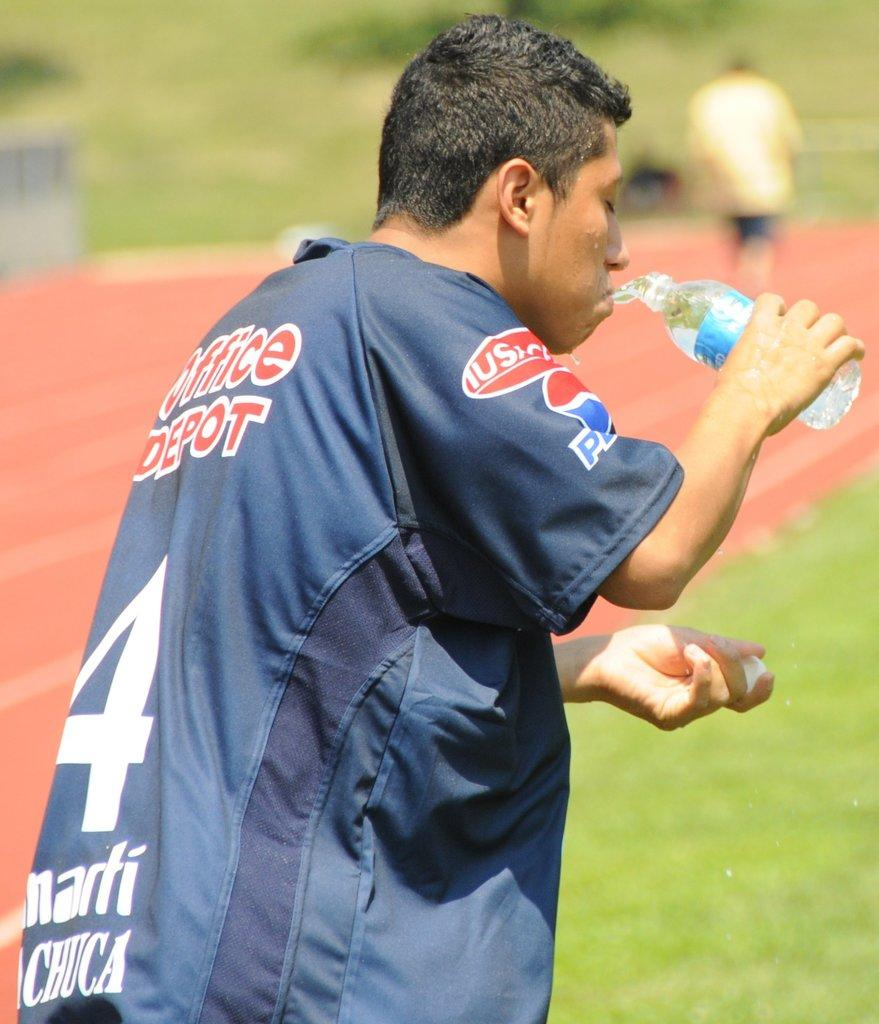What is the person in the image doing? The person is standing in the image and drinking water. What is the person holding in the image? The person is holding a bottle in the image. Can you describe the background of the image? The background of the image is blurred. What type of disgust can be seen on the person's face in the image? There is no indication of disgust on the person's face in the image. How low is the tiger in the image? There is no tiger present in the image. 